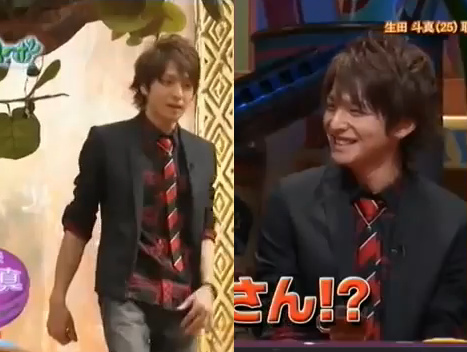What kind of clothing is blue? The coat is blue. 